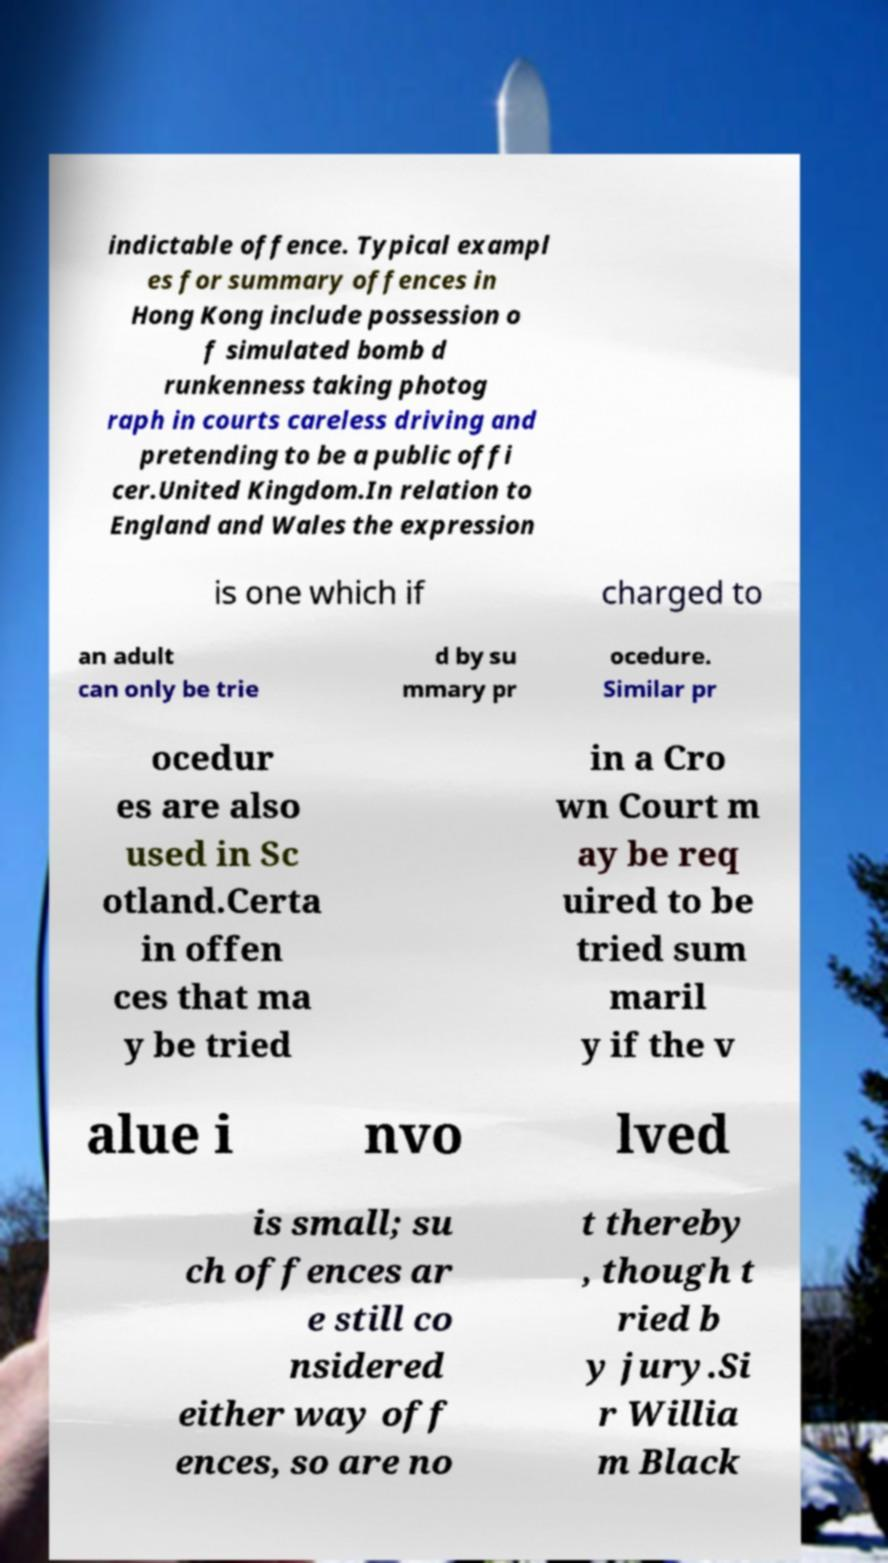Could you extract and type out the text from this image? indictable offence. Typical exampl es for summary offences in Hong Kong include possession o f simulated bomb d runkenness taking photog raph in courts careless driving and pretending to be a public offi cer.United Kingdom.In relation to England and Wales the expression is one which if charged to an adult can only be trie d by su mmary pr ocedure. Similar pr ocedur es are also used in Sc otland.Certa in offen ces that ma y be tried in a Cro wn Court m ay be req uired to be tried sum maril y if the v alue i nvo lved is small; su ch offences ar e still co nsidered either way off ences, so are no t thereby , though t ried b y jury.Si r Willia m Black 